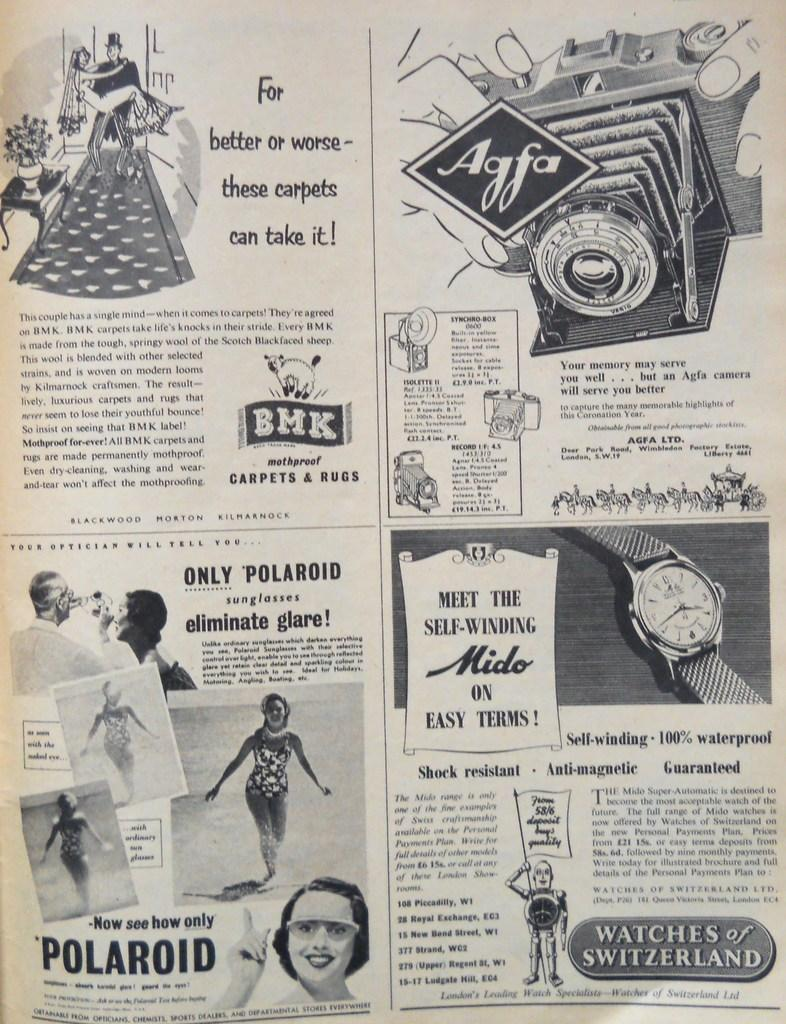<image>
Create a compact narrative representing the image presented. A newspaper ad featuring wool, mothproof carpets from BMK 